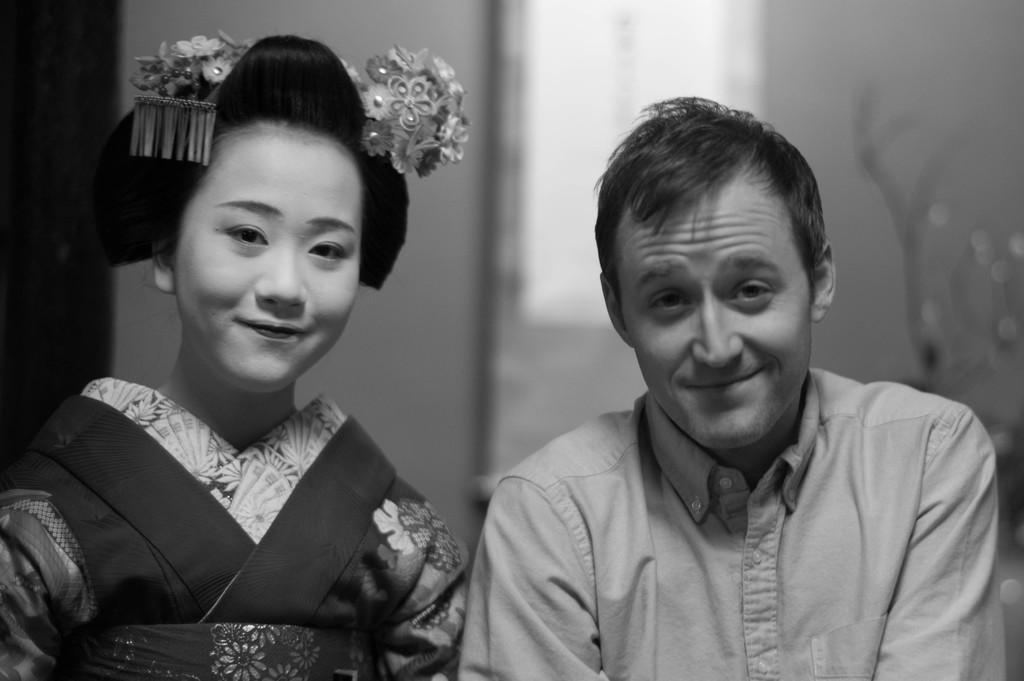How many people are in the image? There are two people in the image. What is the facial expression of the people in the image? The people are smiling. Can you describe the background of the image? The background of the image is blurred. What color scheme is used in the image? The image is in black and white. What type of club is being used in the image? There is no club present in the image. What is the temperature of the oven in the image? There is no oven present in the image. 